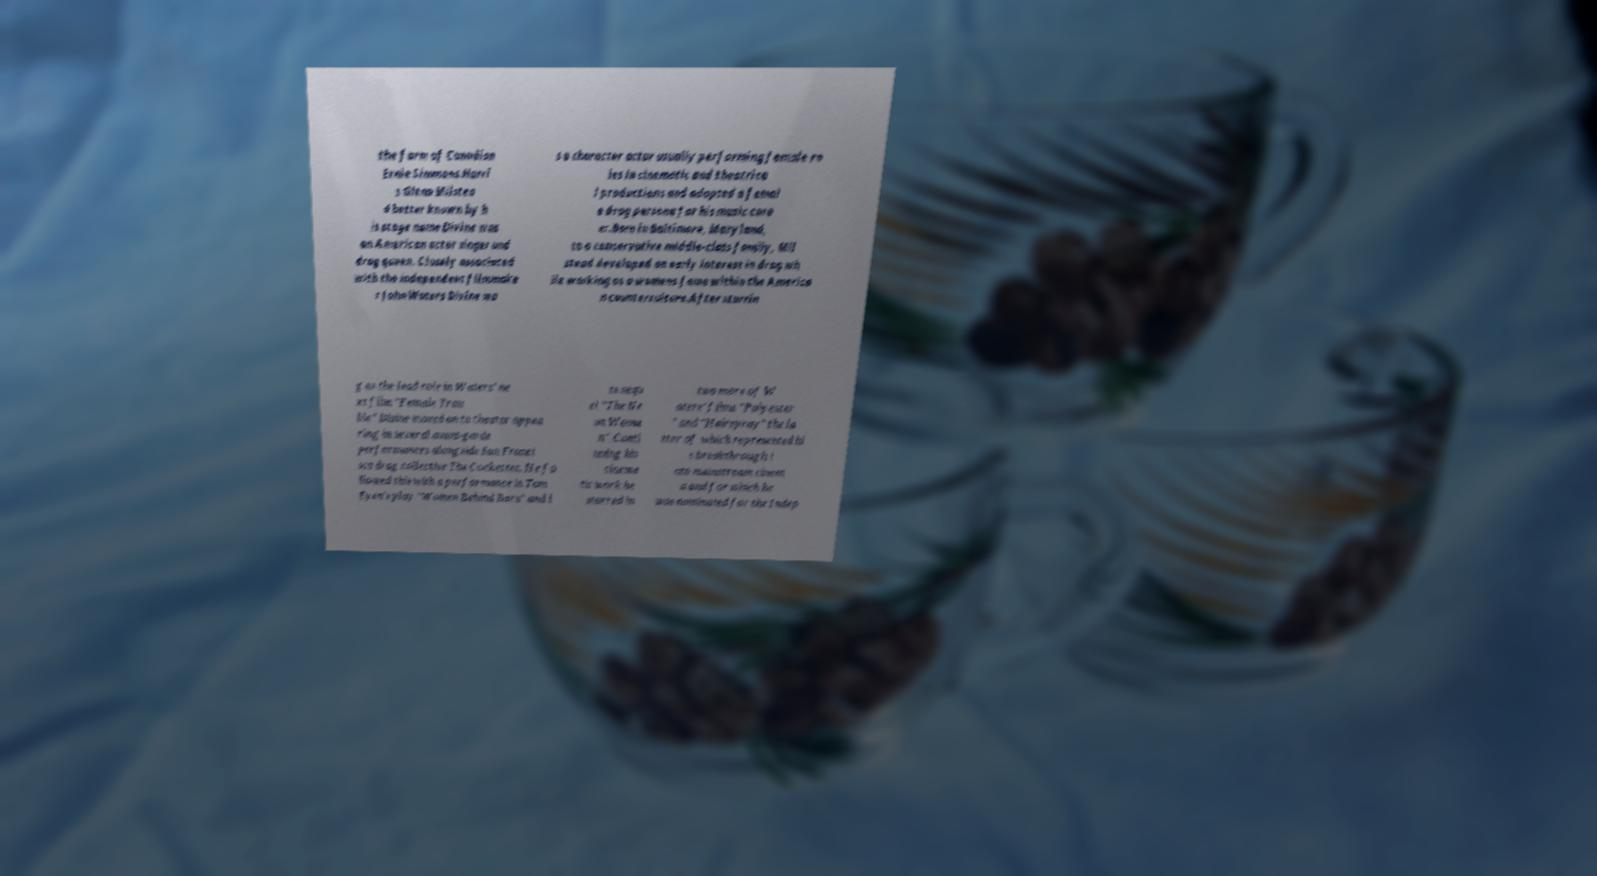What messages or text are displayed in this image? I need them in a readable, typed format. the farm of Canadian Ernie Simmons.Harri s Glenn Milstea d better known by h is stage name Divine was an American actor singer and drag queen. Closely associated with the independent filmmake r John Waters Divine wa s a character actor usually performing female ro les in cinematic and theatrica l productions and adopted a femal e drag persona for his music care er.Born in Baltimore, Maryland, to a conservative middle-class family, Mil stead developed an early interest in drag wh ile working as a womens fame within the America n counterculture.After starrin g as the lead role in Waters' ne xt film "Female Trou ble" Divine moved on to theater appea ring in several avant-garde performances alongside San Franci sco drag collective The Cockettes. He fo llowed this with a performance in Tom Eyen's play "Women Behind Bars" and i ts sequ el "The Ne on Woma n". Conti nuing his cinema tic work he starred in two more of W aters' films "Polyester " and "Hairspray" the la tter of which represented hi s breakthrough i nto mainstream cinem a and for which he was nominated for the Indep 